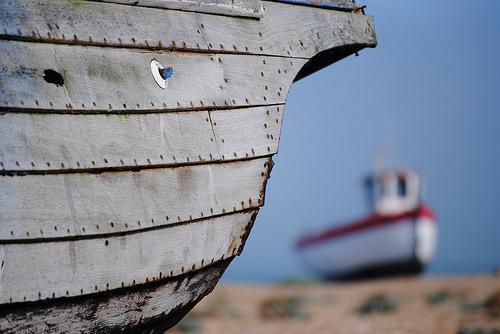How many boats are there?
Give a very brief answer. 2. 